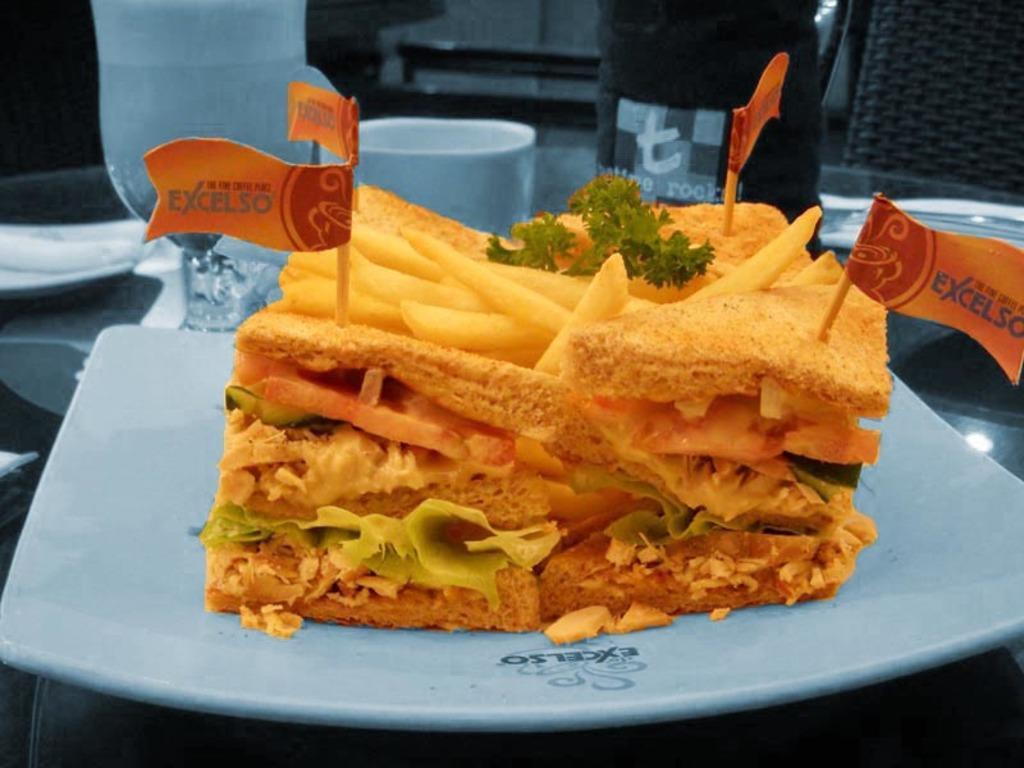Could you give a brief overview of what you see in this image? This is an edited picture. In the foreground of the picture there is a food item, in the plate. In the background there are glass, cup, plate, tissue and chairs. 